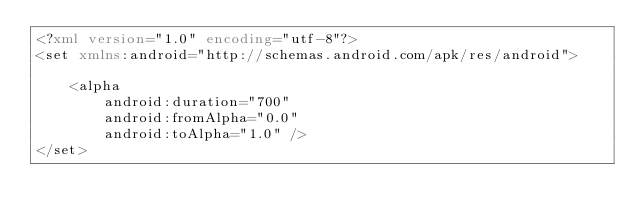Convert code to text. <code><loc_0><loc_0><loc_500><loc_500><_XML_><?xml version="1.0" encoding="utf-8"?>
<set xmlns:android="http://schemas.android.com/apk/res/android">

    <alpha
        android:duration="700"
        android:fromAlpha="0.0"
        android:toAlpha="1.0" />
</set></code> 